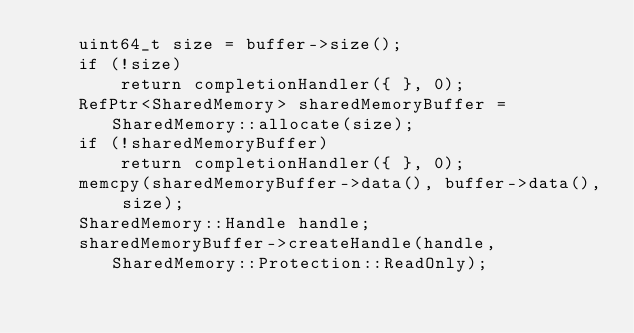<code> <loc_0><loc_0><loc_500><loc_500><_ObjectiveC_>    uint64_t size = buffer->size();
    if (!size)
        return completionHandler({ }, 0);
    RefPtr<SharedMemory> sharedMemoryBuffer = SharedMemory::allocate(size);
    if (!sharedMemoryBuffer)
        return completionHandler({ }, 0);
    memcpy(sharedMemoryBuffer->data(), buffer->data(), size);
    SharedMemory::Handle handle;
    sharedMemoryBuffer->createHandle(handle, SharedMemory::Protection::ReadOnly);</code> 